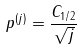Convert formula to latex. <formula><loc_0><loc_0><loc_500><loc_500>p ^ { ( j ) } = \frac { C _ { 1 / 2 } } { \sqrt { j } }</formula> 